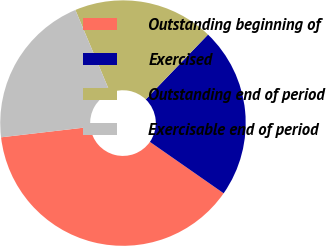<chart> <loc_0><loc_0><loc_500><loc_500><pie_chart><fcel>Outstanding beginning of<fcel>Exercised<fcel>Outstanding end of period<fcel>Exercisable end of period<nl><fcel>38.46%<fcel>22.51%<fcel>18.52%<fcel>20.51%<nl></chart> 